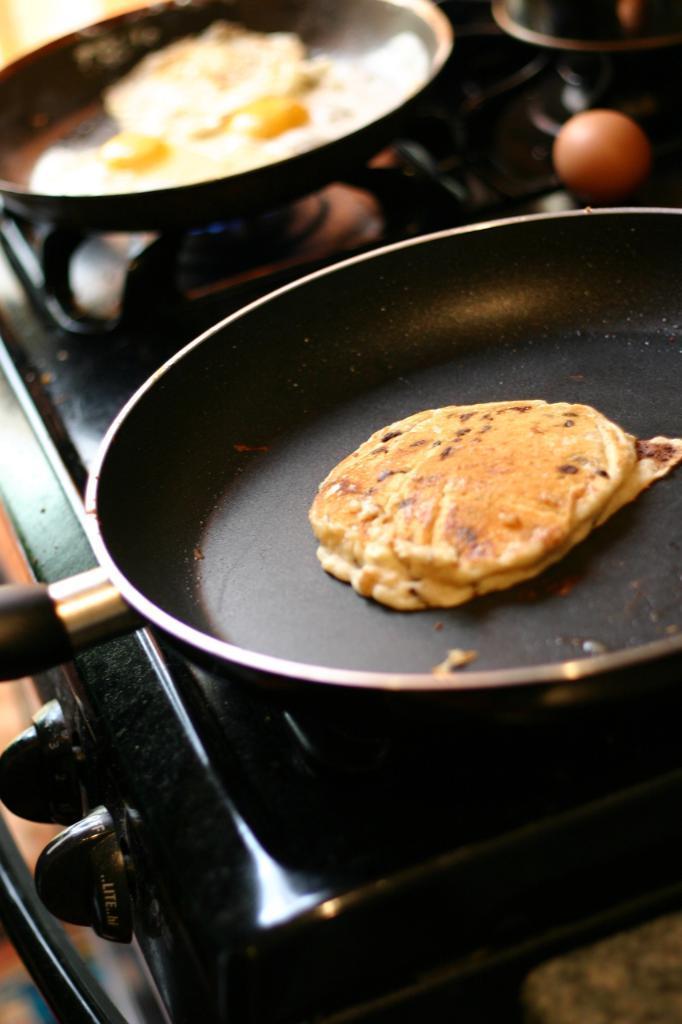How would you summarize this image in a sentence or two? In this picture, there is a stove in the center. On the stove, there are two pans with food. On the top right, there is an egg. 